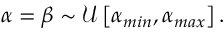Convert formula to latex. <formula><loc_0><loc_0><loc_500><loc_500>\begin{array} { r } { \alpha = \beta \sim \mathcal { U } \left [ \alpha _ { \min } , \alpha _ { \max } \right ] . } \end{array}</formula> 